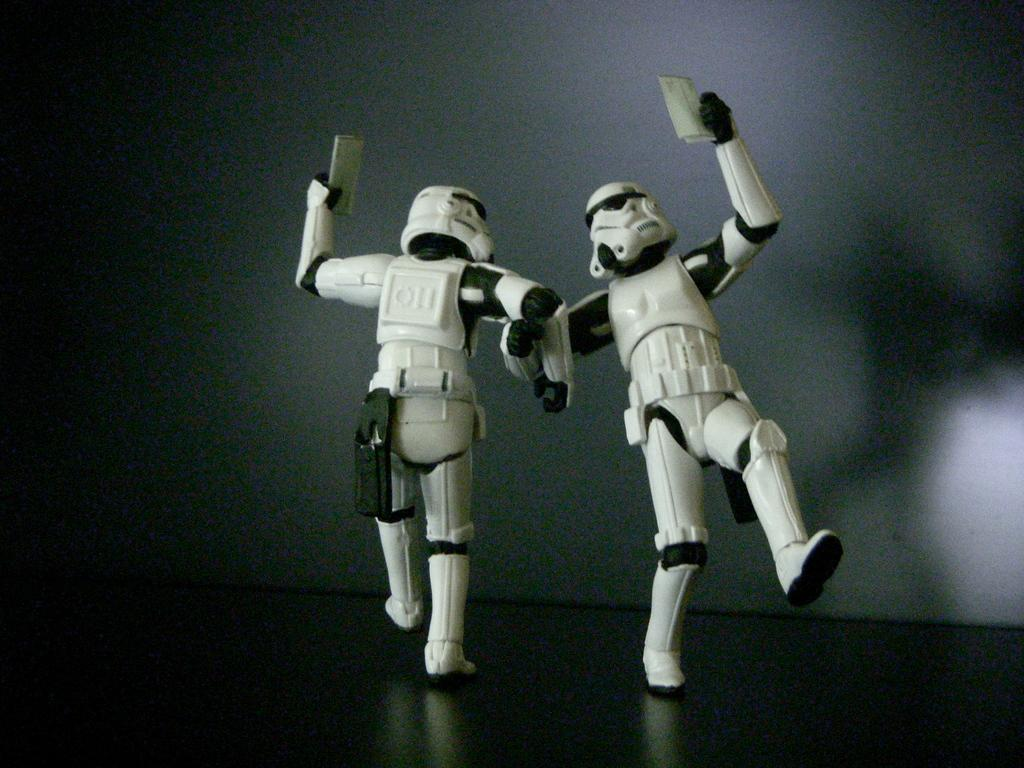How many toys are visible in the image? There are two toys in the image. Where are the toys located? The toys are on a surface. What type of reward is being given to the toys in the image? There is no reward being given to the toys in the image, as the provided facts do not mention any rewards or actions involving the toys. 